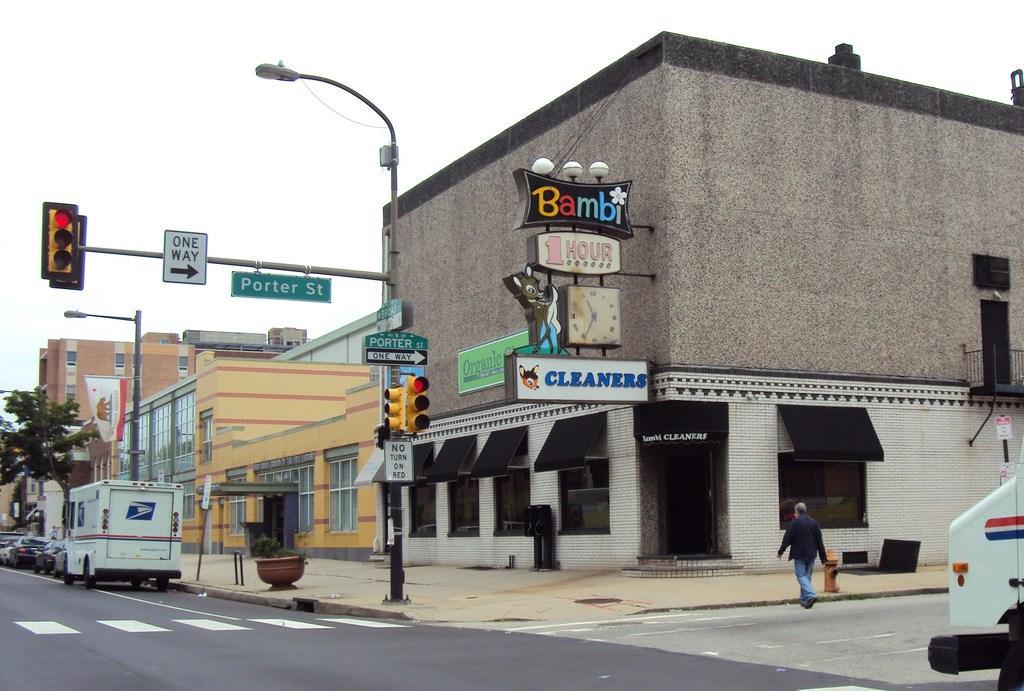Can you describe this image briefly? These are the buildings with windows and glass doors. I can see the direction boards, traffic signals and a street light attached to a pole. These are the vehicles, which are parked beside the road. This looks like a big flower pot with a plant in it. Here is a tree. I can see a person walking. This looks like a fire hydrant. These are the name boards and a clock, which are attached to the building wall. On the right corner of the image, that looks like a vehicle. 